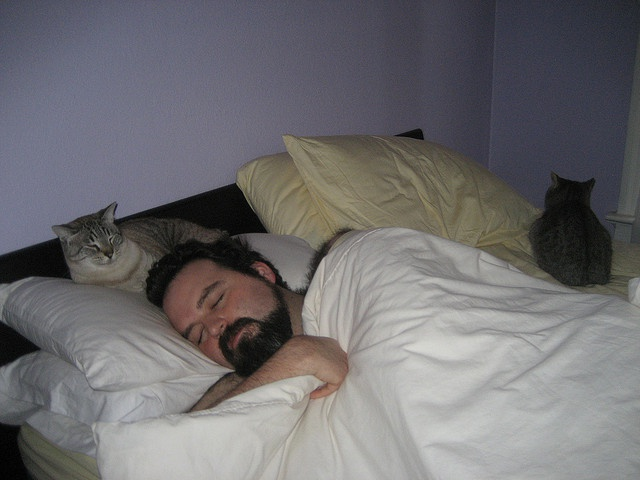Describe the objects in this image and their specific colors. I can see bed in black, darkgray, gray, and lightgray tones, people in black, darkgray, gray, and lightgray tones, cat in black and gray tones, and cat in black and gray tones in this image. 